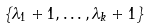Convert formula to latex. <formula><loc_0><loc_0><loc_500><loc_500>\{ \lambda _ { 1 } + 1 , \dots , \lambda _ { k } + 1 \}</formula> 